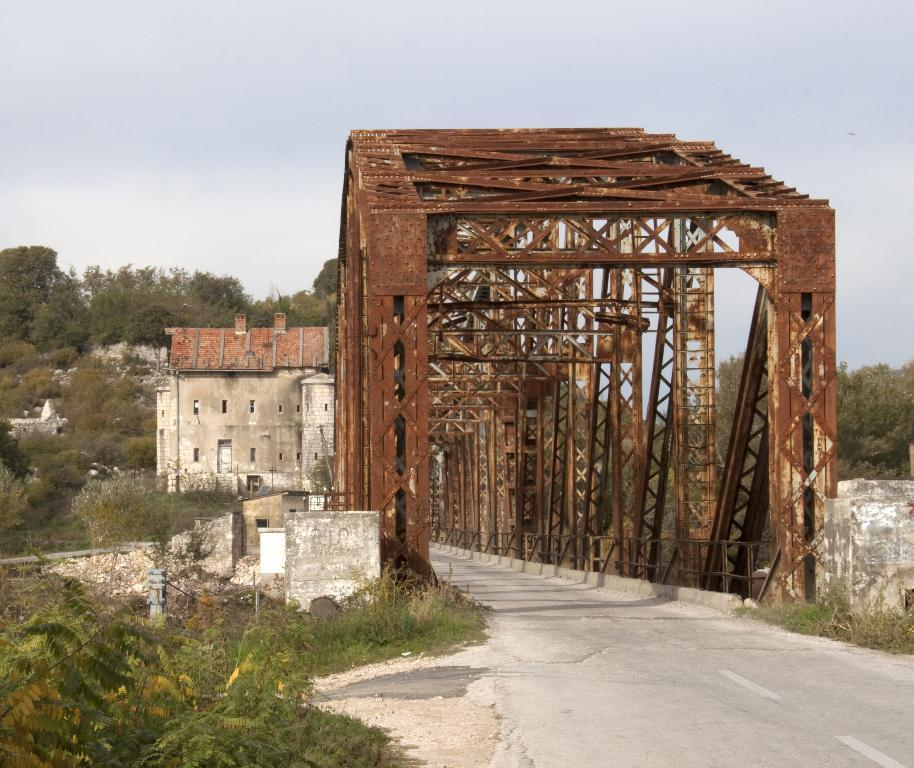What type of bridge is in the image? There is a metal rod bridge in the image. What other natural elements can be seen in the image? There are plants and trees in the image. What man-made structures are present in the image? There are buildings in the image. What is visible at the top of the image? The sky is visible at the top of the image. What day of the week is depicted in the image? The image does not depict a specific day of the week; it is a still image of a bridge, plants, trees, buildings, and the sky. Can you see the tongue of the person who took the photo in the image? There is no person or tongue visible in the image; it is a still image of a bridge, plants, trees, buildings, and the sky. 